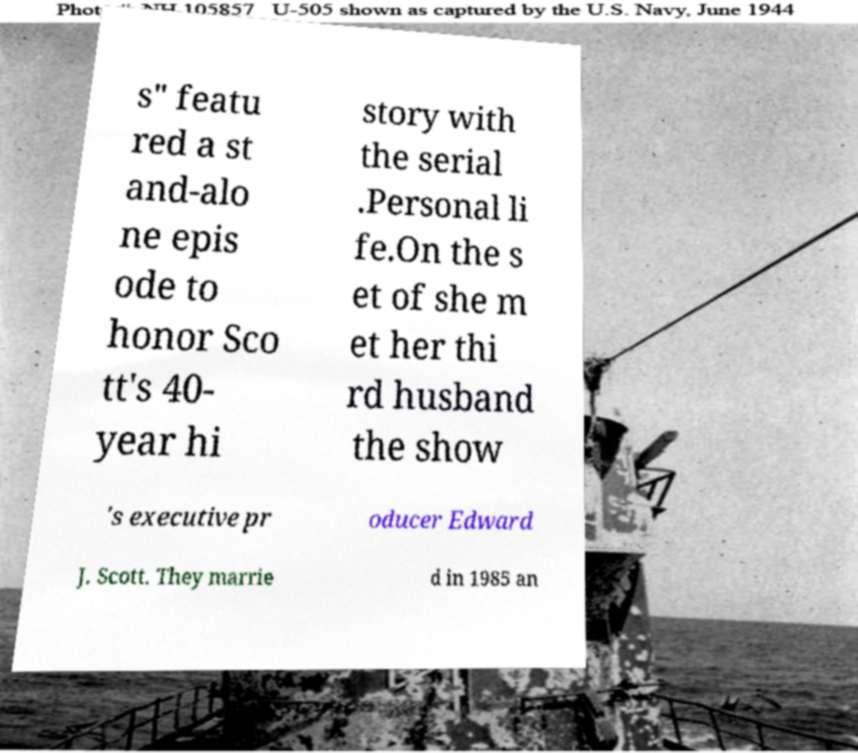There's text embedded in this image that I need extracted. Can you transcribe it verbatim? s" featu red a st and-alo ne epis ode to honor Sco tt's 40- year hi story with the serial .Personal li fe.On the s et of she m et her thi rd husband the show 's executive pr oducer Edward J. Scott. They marrie d in 1985 an 